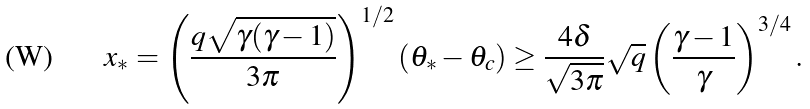<formula> <loc_0><loc_0><loc_500><loc_500>x _ { * } = \left ( \frac { q \sqrt { \gamma ( \gamma - 1 ) } } { 3 \pi } \right ) ^ { 1 / 2 } ( \theta _ { * } - \theta _ { c } ) \geq \frac { 4 \delta } { \sqrt { 3 \pi } } \sqrt { q } \left ( \frac { \gamma - 1 } { \gamma } \right ) ^ { 3 / 4 } .</formula> 